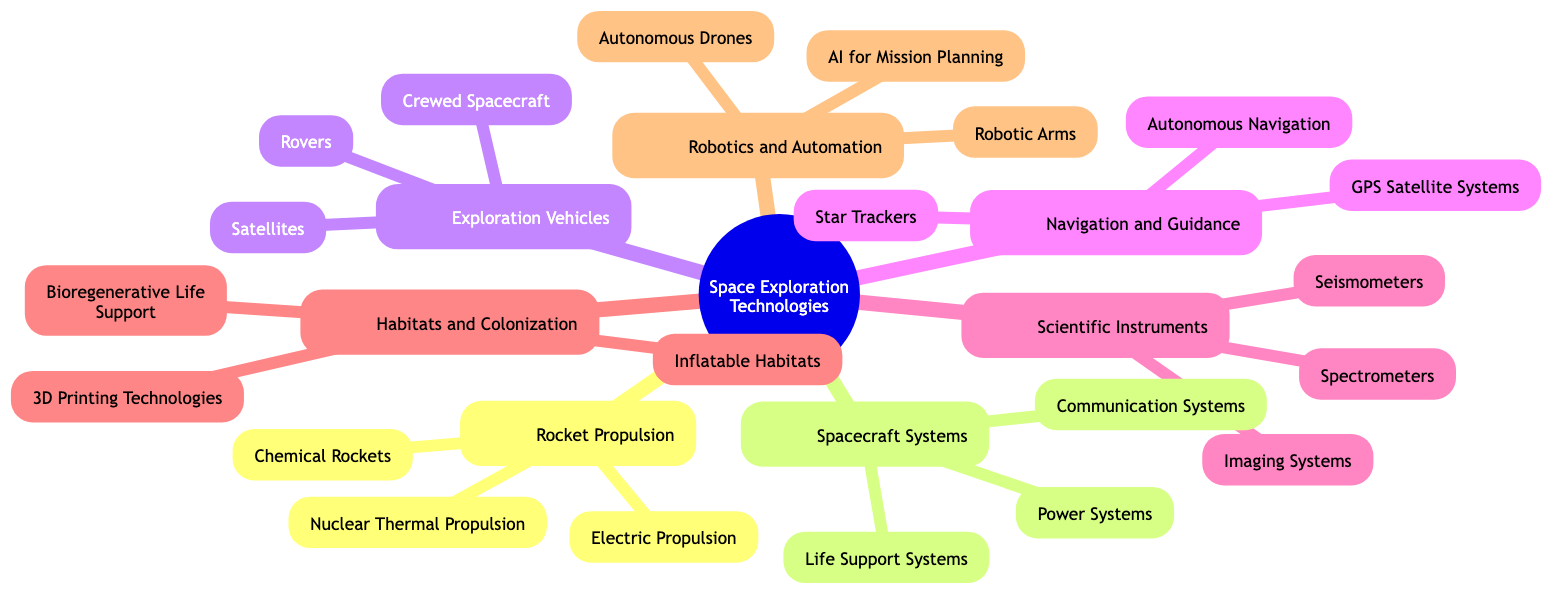What are the three types of rocket propulsion technologies? The mind map shows three sub-elements under the "Rocket Propulsion" topic: Chemical Rockets, Electric Propulsion, and Nuclear Thermal Propulsion.
Answer: Chemical Rockets, Electric Propulsion, Nuclear Thermal Propulsion How many subtopics are listed in the mind map? The central topic, "Key Space Exploration Technologies and Innovations," has seven distinct subtopics listed: Rocket Propulsion, Spacecraft Systems, Exploration Vehicles, Navigation and Guidance, Scientific Instruments, Habitats and Colonization, and Robotics and Automation, making it a total of seven.
Answer: 7 Which topic includes "Life Support Systems"? By examining the subtopics in the diagram, "Life Support Systems" is an element under the "Spacecraft Systems" topic.
Answer: Spacecraft Systems What types of habitats are mentioned in the study of Habitats and Colonization? The "Habitats and Colonization" subtopic lists three elements, which include Inflatable Habitats, 3D Printing Technologies, and Bioregenerative Life Support, signifying the advancements in habitats for space exploration.
Answer: Inflatable Habitats, 3D Printing Technologies, Bioregenerative Life Support Name one type of exploration vehicle featured in the mind map. Looking under the "Exploration Vehicles" subtopic, there are elements like Crewed Spacecraft, Rovers, and Satellites. Any of these would be a valid answer.
Answer: Crewed Spacecraft How is navigation achieved according to the diagram? The "Navigation and Guidance" subtopic lists three elements: GPS Satellite Systems, Star Trackers, and Autonomous Navigation, indicating multiple methods for navigation in space exploration.
Answer: GPS Satellite Systems, Star Trackers, Autonomous Navigation Which subtopic includes "Robotic Arms"? "Robotic Arms" is specifically mentioned under the "Robotics and Automation" subtopic in the diagram, indicating its role in space exploration technology.
Answer: Robotics and Automation Can you list two types of scientific instruments mentioned? The "Scientific Instruments" subtopic shows three elements: Spectrometers, Imaging Systems, and Seismometers. Thus, two can be listed from these.
Answer: Spectrometers, Imaging Systems What is the primary focus of the central topic in this mind map? The central topic, "Key Space Exploration Technologies and Innovations," is concerned with the various technological advancements and innovations facilitating space exploration, integrating the several subtopics.
Answer: Key Space Exploration Technologies and Innovations 